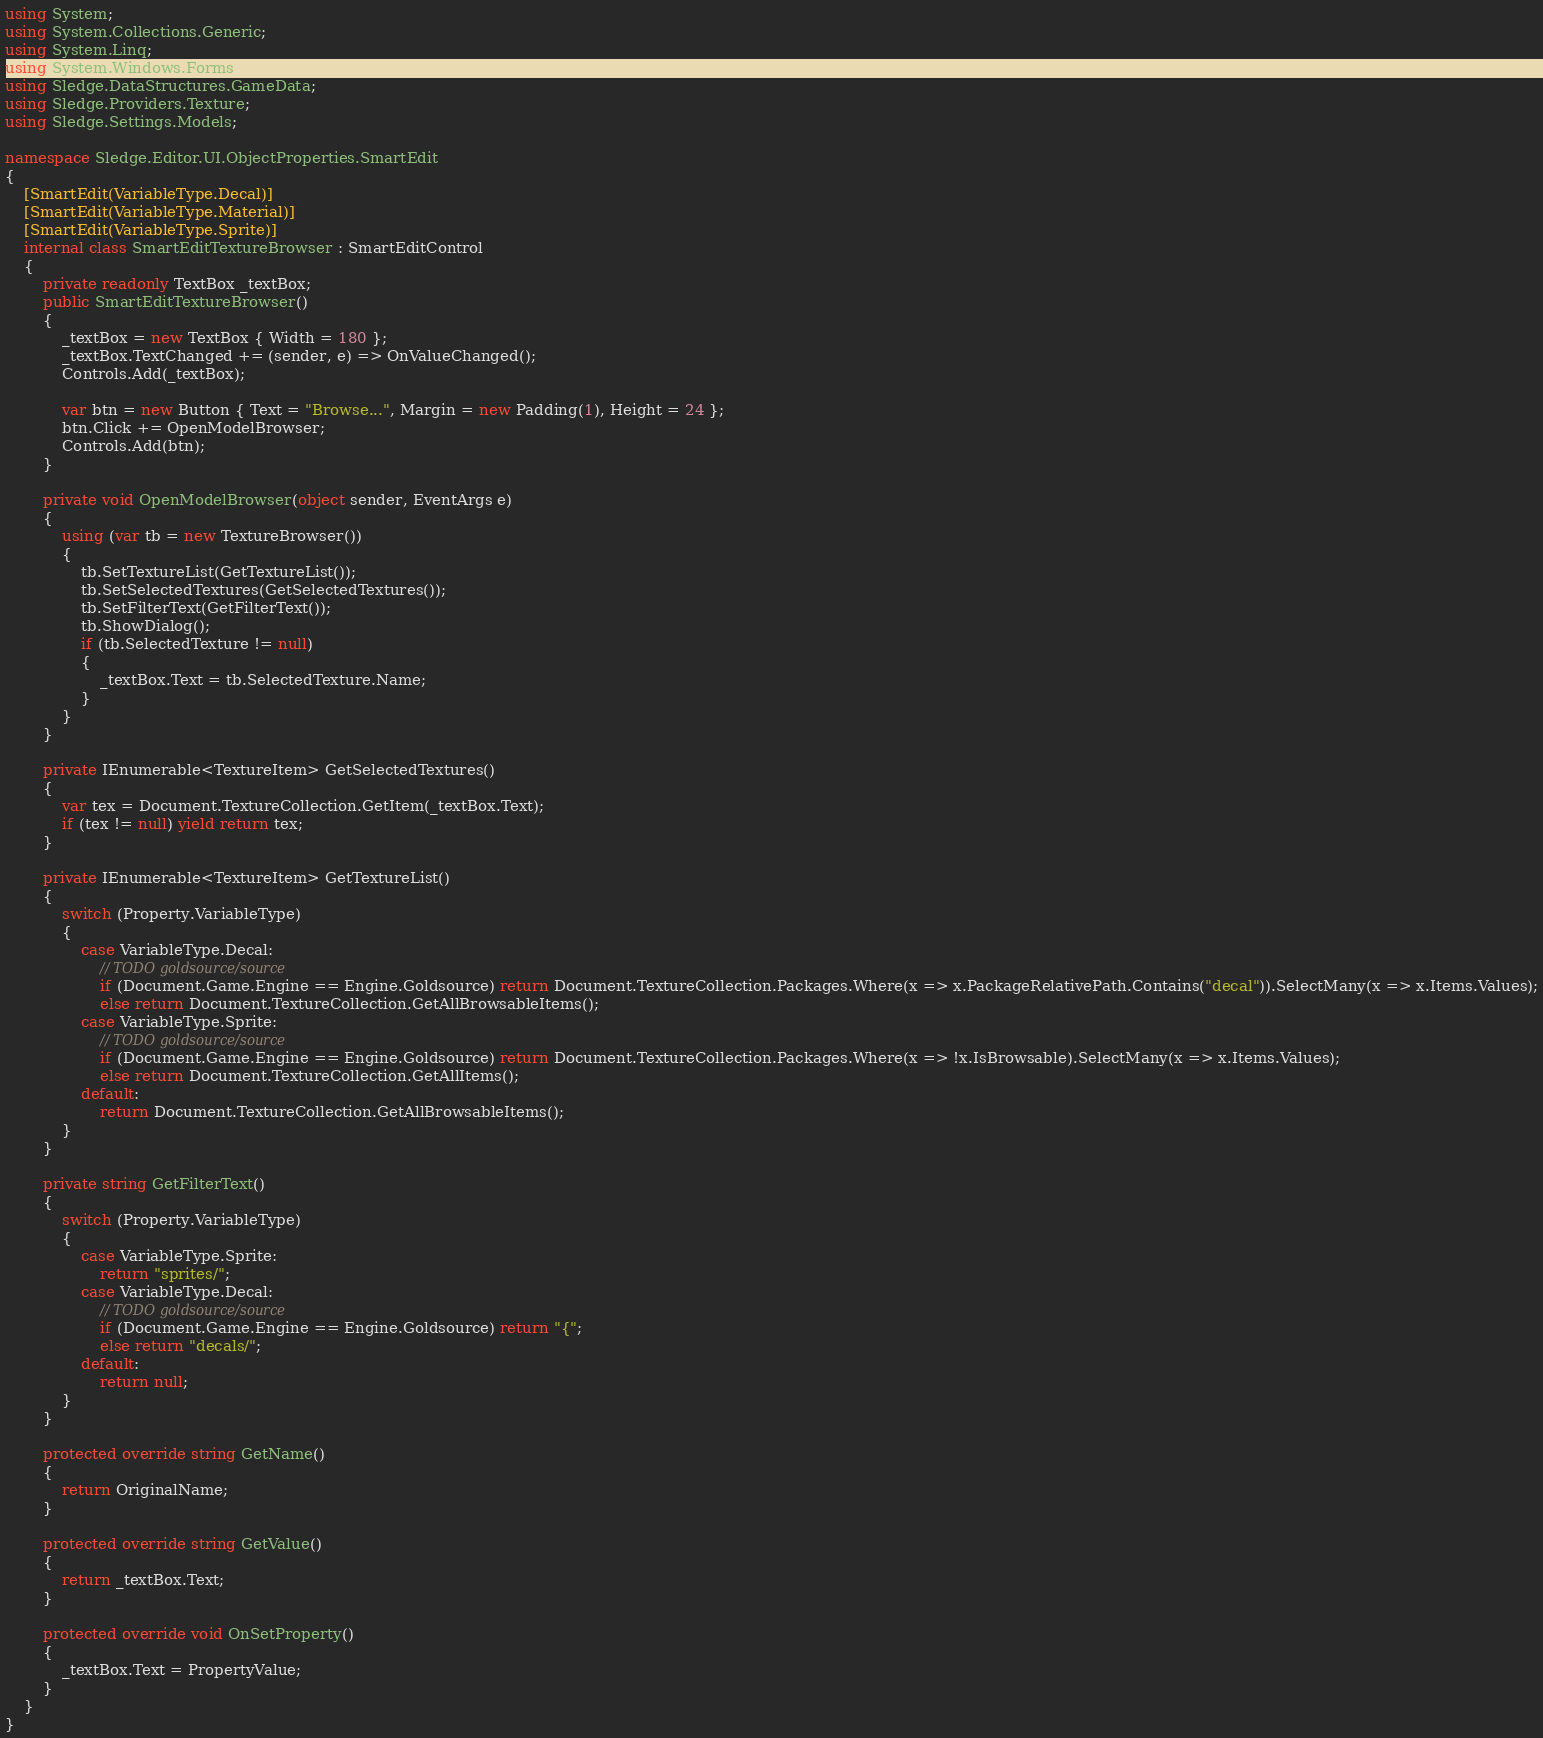Convert code to text. <code><loc_0><loc_0><loc_500><loc_500><_C#_>using System;
using System.Collections.Generic;
using System.Linq;
using System.Windows.Forms;
using Sledge.DataStructures.GameData;
using Sledge.Providers.Texture;
using Sledge.Settings.Models;

namespace Sledge.Editor.UI.ObjectProperties.SmartEdit
{
    [SmartEdit(VariableType.Decal)]
    [SmartEdit(VariableType.Material)]
    [SmartEdit(VariableType.Sprite)]
    internal class SmartEditTextureBrowser : SmartEditControl
    {
        private readonly TextBox _textBox;
        public SmartEditTextureBrowser()
        {
            _textBox = new TextBox { Width = 180 };
            _textBox.TextChanged += (sender, e) => OnValueChanged();
            Controls.Add(_textBox);

            var btn = new Button { Text = "Browse...", Margin = new Padding(1), Height = 24 };
            btn.Click += OpenModelBrowser;
            Controls.Add(btn);
        }

        private void OpenModelBrowser(object sender, EventArgs e)
        {
            using (var tb = new TextureBrowser())
            {
                tb.SetTextureList(GetTextureList());
                tb.SetSelectedTextures(GetSelectedTextures());
                tb.SetFilterText(GetFilterText());
                tb.ShowDialog();
                if (tb.SelectedTexture != null)
                {
                    _textBox.Text = tb.SelectedTexture.Name;
                }
            }
        }

        private IEnumerable<TextureItem> GetSelectedTextures()
        {
            var tex = Document.TextureCollection.GetItem(_textBox.Text);
            if (tex != null) yield return tex;
        }

        private IEnumerable<TextureItem> GetTextureList()
        {
            switch (Property.VariableType)
            {
                case VariableType.Decal:
                    // TODO goldsource/source
                    if (Document.Game.Engine == Engine.Goldsource) return Document.TextureCollection.Packages.Where(x => x.PackageRelativePath.Contains("decal")).SelectMany(x => x.Items.Values);
                    else return Document.TextureCollection.GetAllBrowsableItems();
                case VariableType.Sprite:
                    // TODO goldsource/source
                    if (Document.Game.Engine == Engine.Goldsource) return Document.TextureCollection.Packages.Where(x => !x.IsBrowsable).SelectMany(x => x.Items.Values);
                    else return Document.TextureCollection.GetAllItems();
                default:
                    return Document.TextureCollection.GetAllBrowsableItems();
            }
        }

        private string GetFilterText()
        {
            switch (Property.VariableType)
            {
                case VariableType.Sprite:
                    return "sprites/";
                case VariableType.Decal:
                    // TODO goldsource/source
                    if (Document.Game.Engine == Engine.Goldsource) return "{";
                    else return "decals/";
                default:
                    return null;
            }
        }

        protected override string GetName()
        {
            return OriginalName;
        }

        protected override string GetValue()
        {
            return _textBox.Text;
        }

        protected override void OnSetProperty()
        {
            _textBox.Text = PropertyValue;
        }
    }
}</code> 